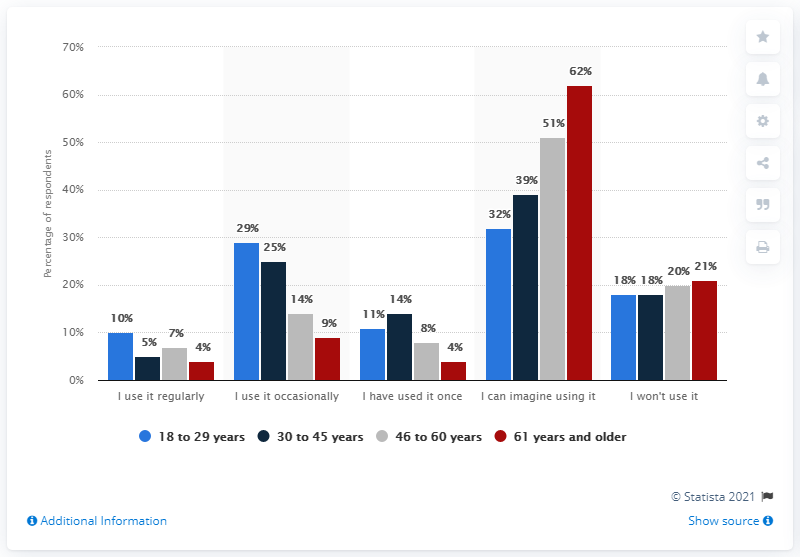Outline some significant characteristics in this image. According to a recent survey, 4% of individuals aged 61 and older used apps for self-diagnosis. According to a recent survey, 10% of adults aged 18 to 29 reported using apps for self-diagnosis on a regular basis. 